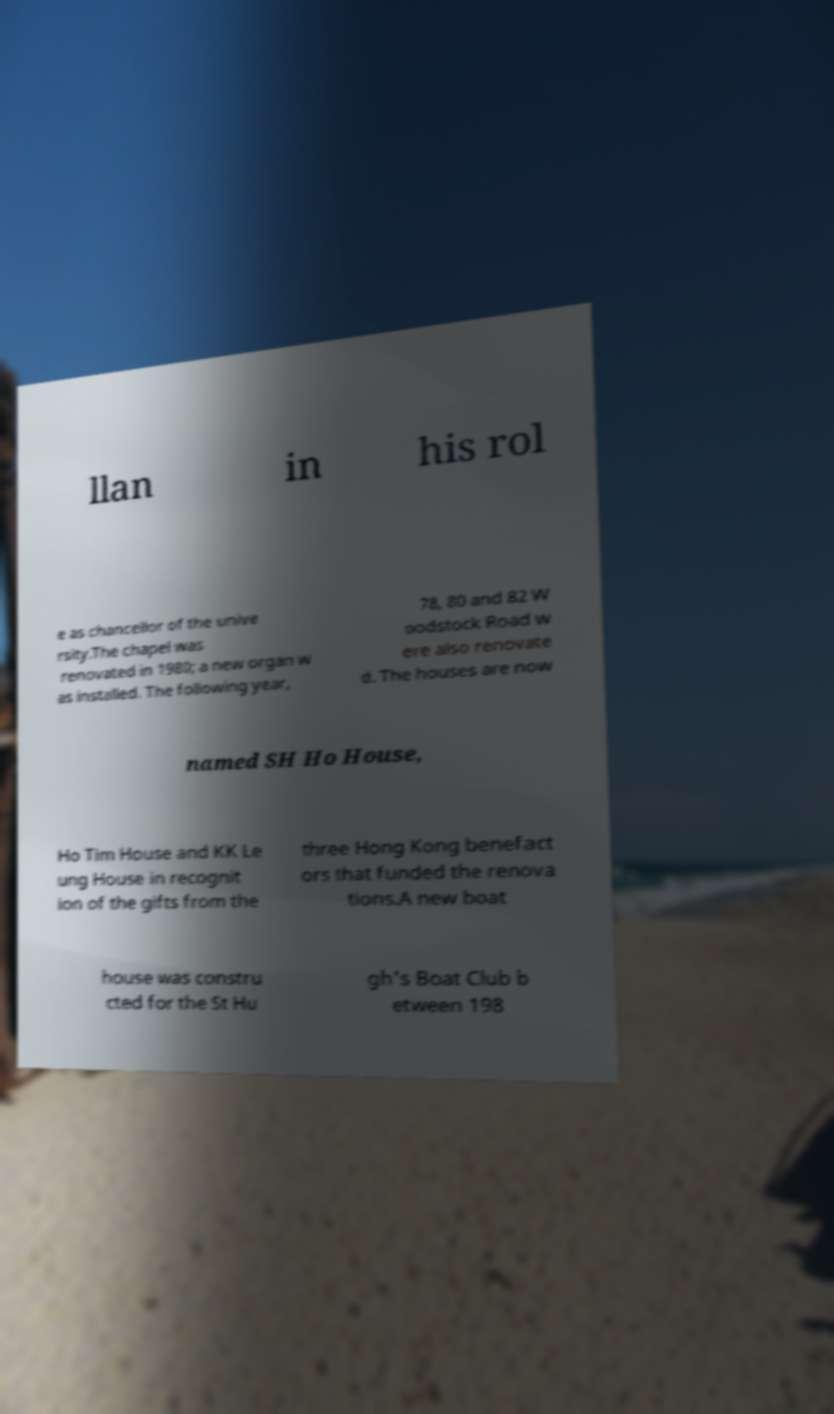There's text embedded in this image that I need extracted. Can you transcribe it verbatim? llan in his rol e as chancellor of the unive rsity.The chapel was renovated in 1980; a new organ w as installed. The following year, 78, 80 and 82 W oodstock Road w ere also renovate d. The houses are now named SH Ho House, Ho Tim House and KK Le ung House in recognit ion of the gifts from the three Hong Kong benefact ors that funded the renova tions.A new boat house was constru cted for the St Hu gh's Boat Club b etween 198 